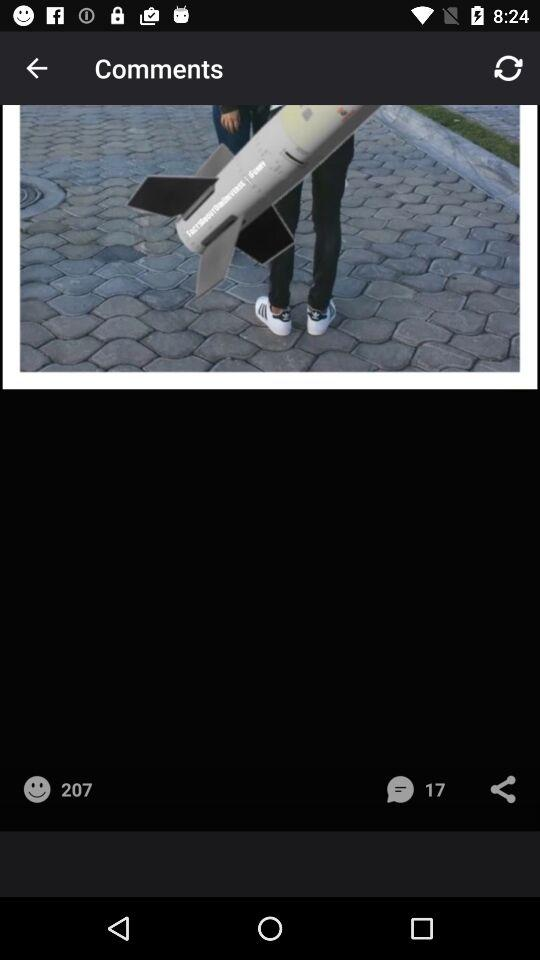How many likes are there? There are 207 likes. 